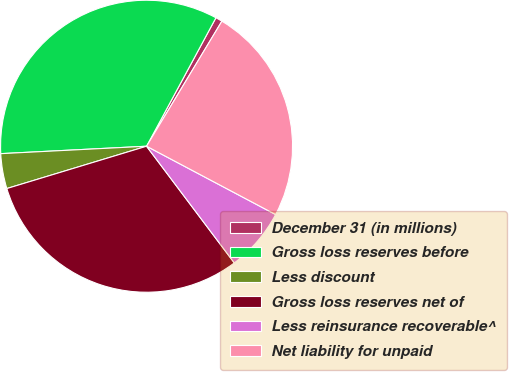Convert chart. <chart><loc_0><loc_0><loc_500><loc_500><pie_chart><fcel>December 31 (in millions)<fcel>Gross loss reserves before<fcel>Less discount<fcel>Gross loss reserves net of<fcel>Less reinsurance recoverable^<fcel>Net liability for unpaid<nl><fcel>0.75%<fcel>33.69%<fcel>3.87%<fcel>30.58%<fcel>6.99%<fcel>24.12%<nl></chart> 